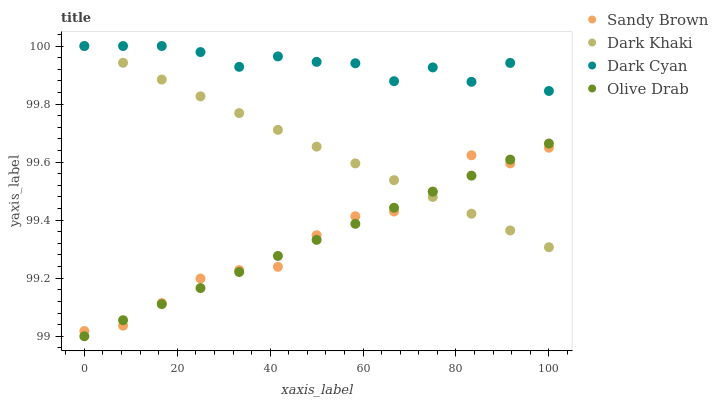Does Olive Drab have the minimum area under the curve?
Answer yes or no. Yes. Does Dark Cyan have the maximum area under the curve?
Answer yes or no. Yes. Does Sandy Brown have the minimum area under the curve?
Answer yes or no. No. Does Sandy Brown have the maximum area under the curve?
Answer yes or no. No. Is Olive Drab the smoothest?
Answer yes or no. Yes. Is Dark Cyan the roughest?
Answer yes or no. Yes. Is Sandy Brown the smoothest?
Answer yes or no. No. Is Sandy Brown the roughest?
Answer yes or no. No. Does Olive Drab have the lowest value?
Answer yes or no. Yes. Does Sandy Brown have the lowest value?
Answer yes or no. No. Does Dark Cyan have the highest value?
Answer yes or no. Yes. Does Sandy Brown have the highest value?
Answer yes or no. No. Is Sandy Brown less than Dark Cyan?
Answer yes or no. Yes. Is Dark Cyan greater than Olive Drab?
Answer yes or no. Yes. Does Dark Cyan intersect Dark Khaki?
Answer yes or no. Yes. Is Dark Cyan less than Dark Khaki?
Answer yes or no. No. Is Dark Cyan greater than Dark Khaki?
Answer yes or no. No. Does Sandy Brown intersect Dark Cyan?
Answer yes or no. No. 